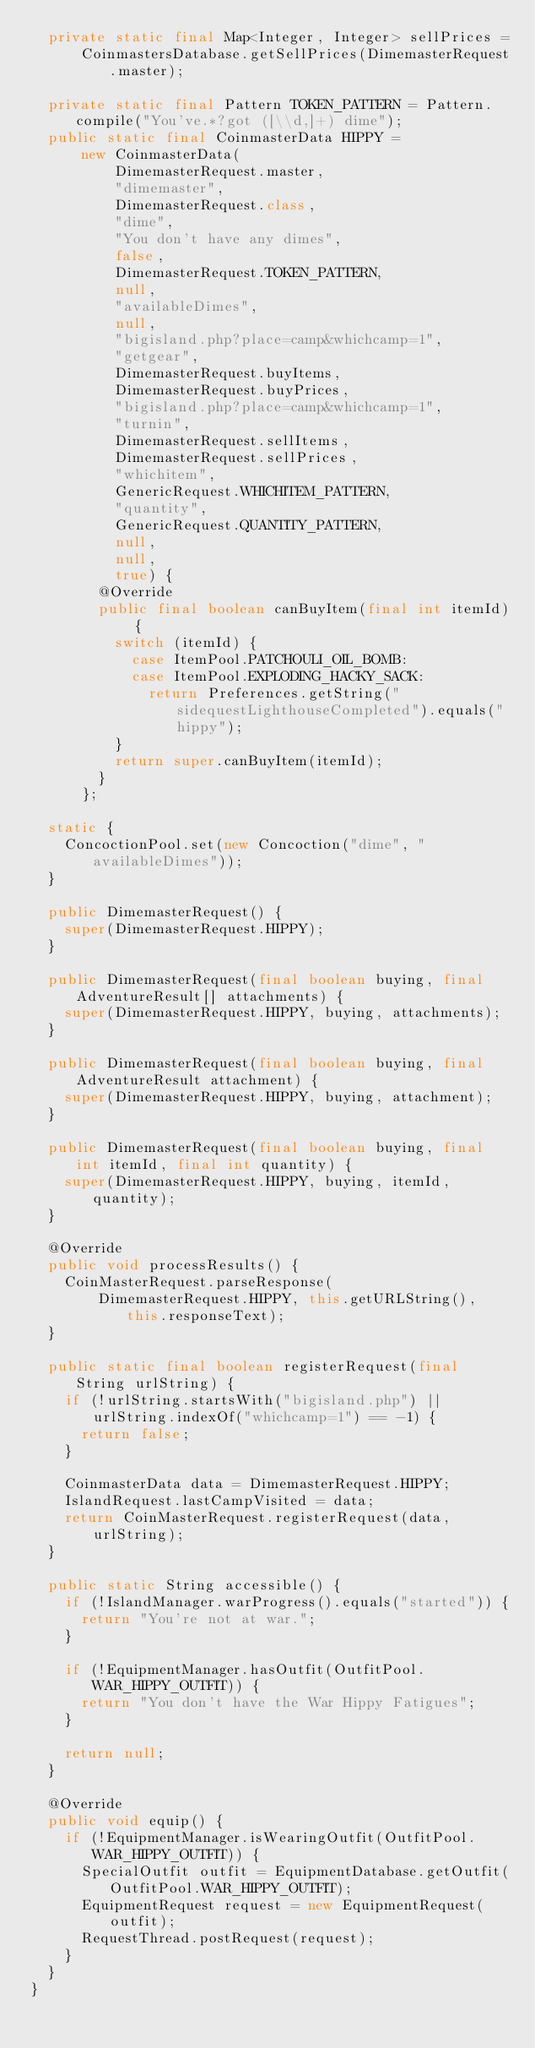<code> <loc_0><loc_0><loc_500><loc_500><_Java_>  private static final Map<Integer, Integer> sellPrices =
      CoinmastersDatabase.getSellPrices(DimemasterRequest.master);

  private static final Pattern TOKEN_PATTERN = Pattern.compile("You've.*?got ([\\d,]+) dime");
  public static final CoinmasterData HIPPY =
      new CoinmasterData(
          DimemasterRequest.master,
          "dimemaster",
          DimemasterRequest.class,
          "dime",
          "You don't have any dimes",
          false,
          DimemasterRequest.TOKEN_PATTERN,
          null,
          "availableDimes",
          null,
          "bigisland.php?place=camp&whichcamp=1",
          "getgear",
          DimemasterRequest.buyItems,
          DimemasterRequest.buyPrices,
          "bigisland.php?place=camp&whichcamp=1",
          "turnin",
          DimemasterRequest.sellItems,
          DimemasterRequest.sellPrices,
          "whichitem",
          GenericRequest.WHICHITEM_PATTERN,
          "quantity",
          GenericRequest.QUANTITY_PATTERN,
          null,
          null,
          true) {
        @Override
        public final boolean canBuyItem(final int itemId) {
          switch (itemId) {
            case ItemPool.PATCHOULI_OIL_BOMB:
            case ItemPool.EXPLODING_HACKY_SACK:
              return Preferences.getString("sidequestLighthouseCompleted").equals("hippy");
          }
          return super.canBuyItem(itemId);
        }
      };

  static {
    ConcoctionPool.set(new Concoction("dime", "availableDimes"));
  }

  public DimemasterRequest() {
    super(DimemasterRequest.HIPPY);
  }

  public DimemasterRequest(final boolean buying, final AdventureResult[] attachments) {
    super(DimemasterRequest.HIPPY, buying, attachments);
  }

  public DimemasterRequest(final boolean buying, final AdventureResult attachment) {
    super(DimemasterRequest.HIPPY, buying, attachment);
  }

  public DimemasterRequest(final boolean buying, final int itemId, final int quantity) {
    super(DimemasterRequest.HIPPY, buying, itemId, quantity);
  }

  @Override
  public void processResults() {
    CoinMasterRequest.parseResponse(
        DimemasterRequest.HIPPY, this.getURLString(), this.responseText);
  }

  public static final boolean registerRequest(final String urlString) {
    if (!urlString.startsWith("bigisland.php") || urlString.indexOf("whichcamp=1") == -1) {
      return false;
    }

    CoinmasterData data = DimemasterRequest.HIPPY;
    IslandRequest.lastCampVisited = data;
    return CoinMasterRequest.registerRequest(data, urlString);
  }

  public static String accessible() {
    if (!IslandManager.warProgress().equals("started")) {
      return "You're not at war.";
    }

    if (!EquipmentManager.hasOutfit(OutfitPool.WAR_HIPPY_OUTFIT)) {
      return "You don't have the War Hippy Fatigues";
    }

    return null;
  }

  @Override
  public void equip() {
    if (!EquipmentManager.isWearingOutfit(OutfitPool.WAR_HIPPY_OUTFIT)) {
      SpecialOutfit outfit = EquipmentDatabase.getOutfit(OutfitPool.WAR_HIPPY_OUTFIT);
      EquipmentRequest request = new EquipmentRequest(outfit);
      RequestThread.postRequest(request);
    }
  }
}
</code> 